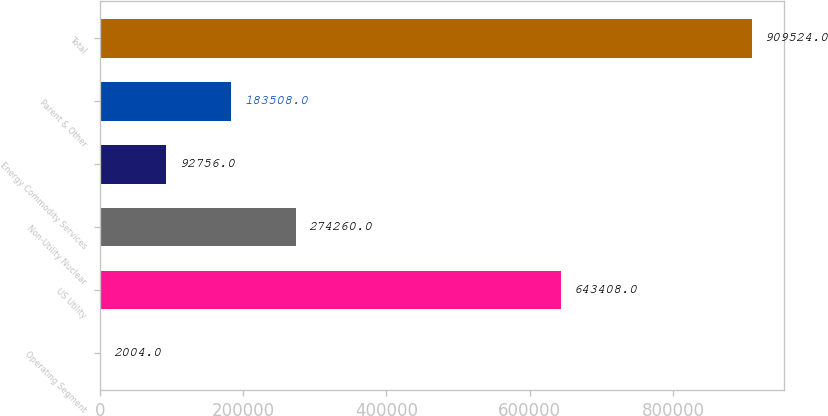Convert chart to OTSL. <chart><loc_0><loc_0><loc_500><loc_500><bar_chart><fcel>Operating Segment<fcel>US Utility<fcel>Non-Utility Nuclear<fcel>Energy Commodity Services<fcel>Parent & Other<fcel>Total<nl><fcel>2004<fcel>643408<fcel>274260<fcel>92756<fcel>183508<fcel>909524<nl></chart> 